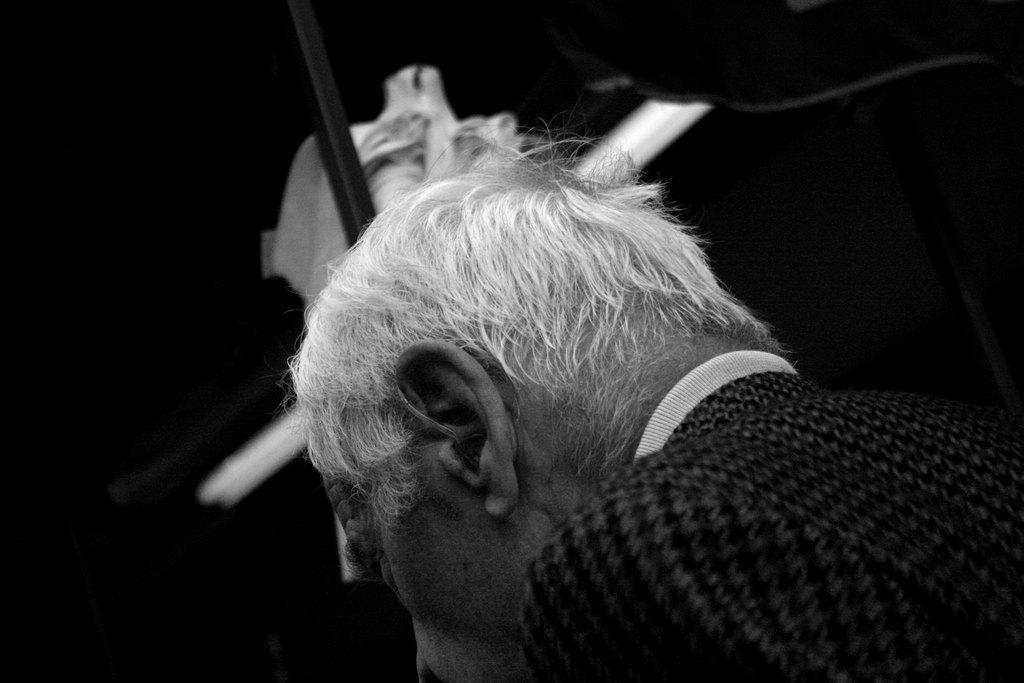Please provide a concise description of this image. In this picture there is a man who is wearing black dress. Beside him we can see poles or pipes. On the left we can see darkness. 